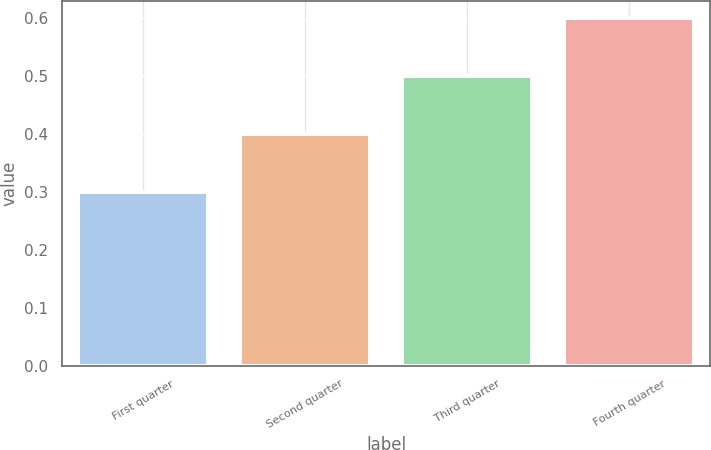<chart> <loc_0><loc_0><loc_500><loc_500><bar_chart><fcel>First quarter<fcel>Second quarter<fcel>Third quarter<fcel>Fourth quarter<nl><fcel>0.3<fcel>0.4<fcel>0.5<fcel>0.6<nl></chart> 